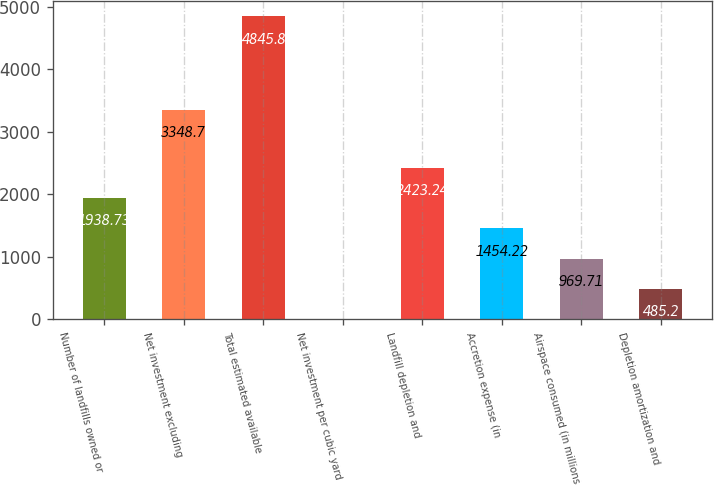Convert chart to OTSL. <chart><loc_0><loc_0><loc_500><loc_500><bar_chart><fcel>Number of landfills owned or<fcel>Net investment excluding<fcel>Total estimated available<fcel>Net investment per cubic yard<fcel>Landfill depletion and<fcel>Accretion expense (in<fcel>Airspace consumed (in millions<fcel>Depletion amortization and<nl><fcel>1938.73<fcel>3348.7<fcel>4845.8<fcel>0.69<fcel>2423.24<fcel>1454.22<fcel>969.71<fcel>485.2<nl></chart> 